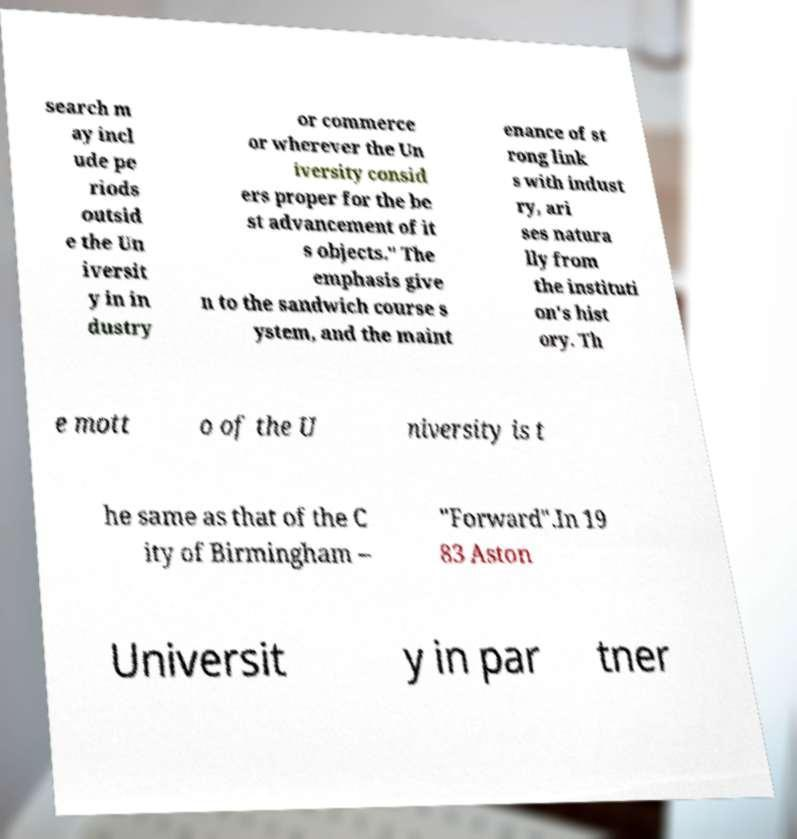Can you read and provide the text displayed in the image?This photo seems to have some interesting text. Can you extract and type it out for me? search m ay incl ude pe riods outsid e the Un iversit y in in dustry or commerce or wherever the Un iversity consid ers proper for the be st advancement of it s objects." The emphasis give n to the sandwich course s ystem, and the maint enance of st rong link s with indust ry, ari ses natura lly from the instituti on's hist ory. Th e mott o of the U niversity is t he same as that of the C ity of Birmingham – "Forward".In 19 83 Aston Universit y in par tner 